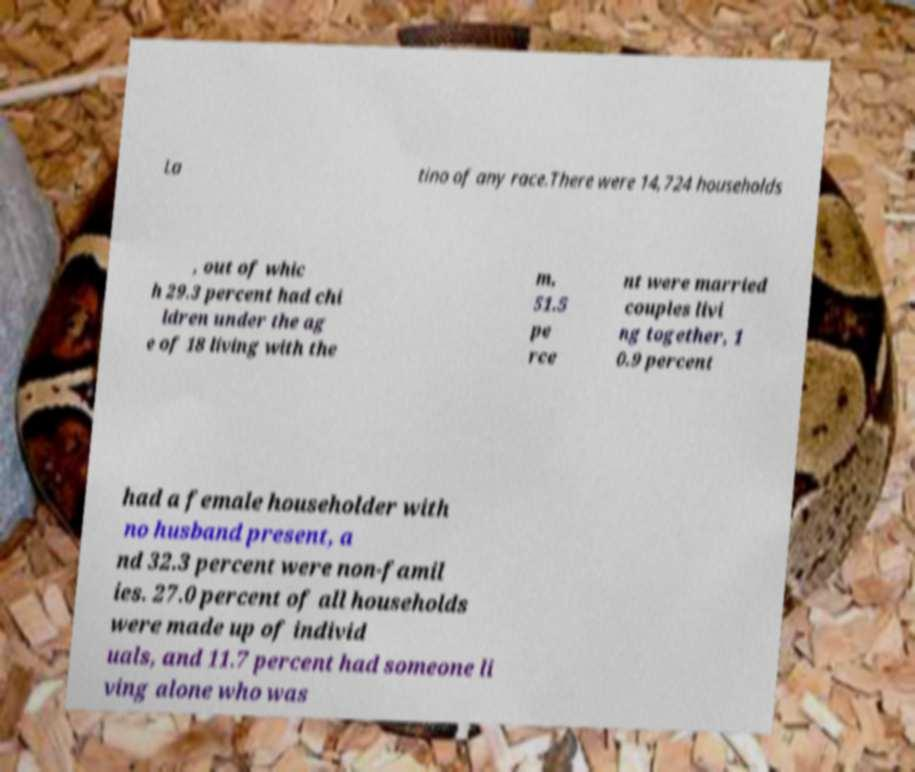Could you assist in decoding the text presented in this image and type it out clearly? La tino of any race.There were 14,724 households , out of whic h 29.3 percent had chi ldren under the ag e of 18 living with the m, 51.5 pe rce nt were married couples livi ng together, 1 0.9 percent had a female householder with no husband present, a nd 32.3 percent were non-famil ies. 27.0 percent of all households were made up of individ uals, and 11.7 percent had someone li ving alone who was 